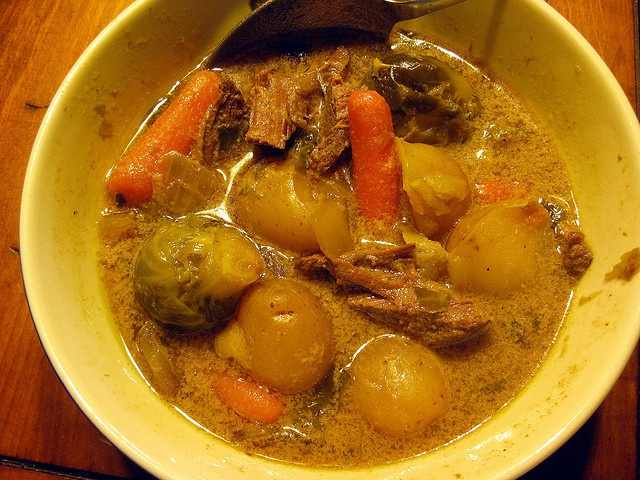Describe the objects in this image and their specific colors. I can see bowl in olive, maroon, orange, and gold tones, dining table in maroon, red, and orange tones, spoon in maroon, black, and olive tones, carrot in maroon, red, orange, and brown tones, and carrot in maroon, brown, and red tones in this image. 